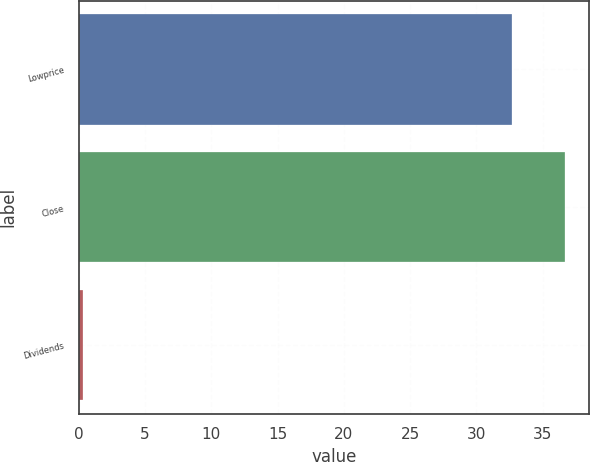Convert chart. <chart><loc_0><loc_0><loc_500><loc_500><bar_chart><fcel>Lowprice<fcel>Close<fcel>Dividends<nl><fcel>32.69<fcel>36.69<fcel>0.3<nl></chart> 